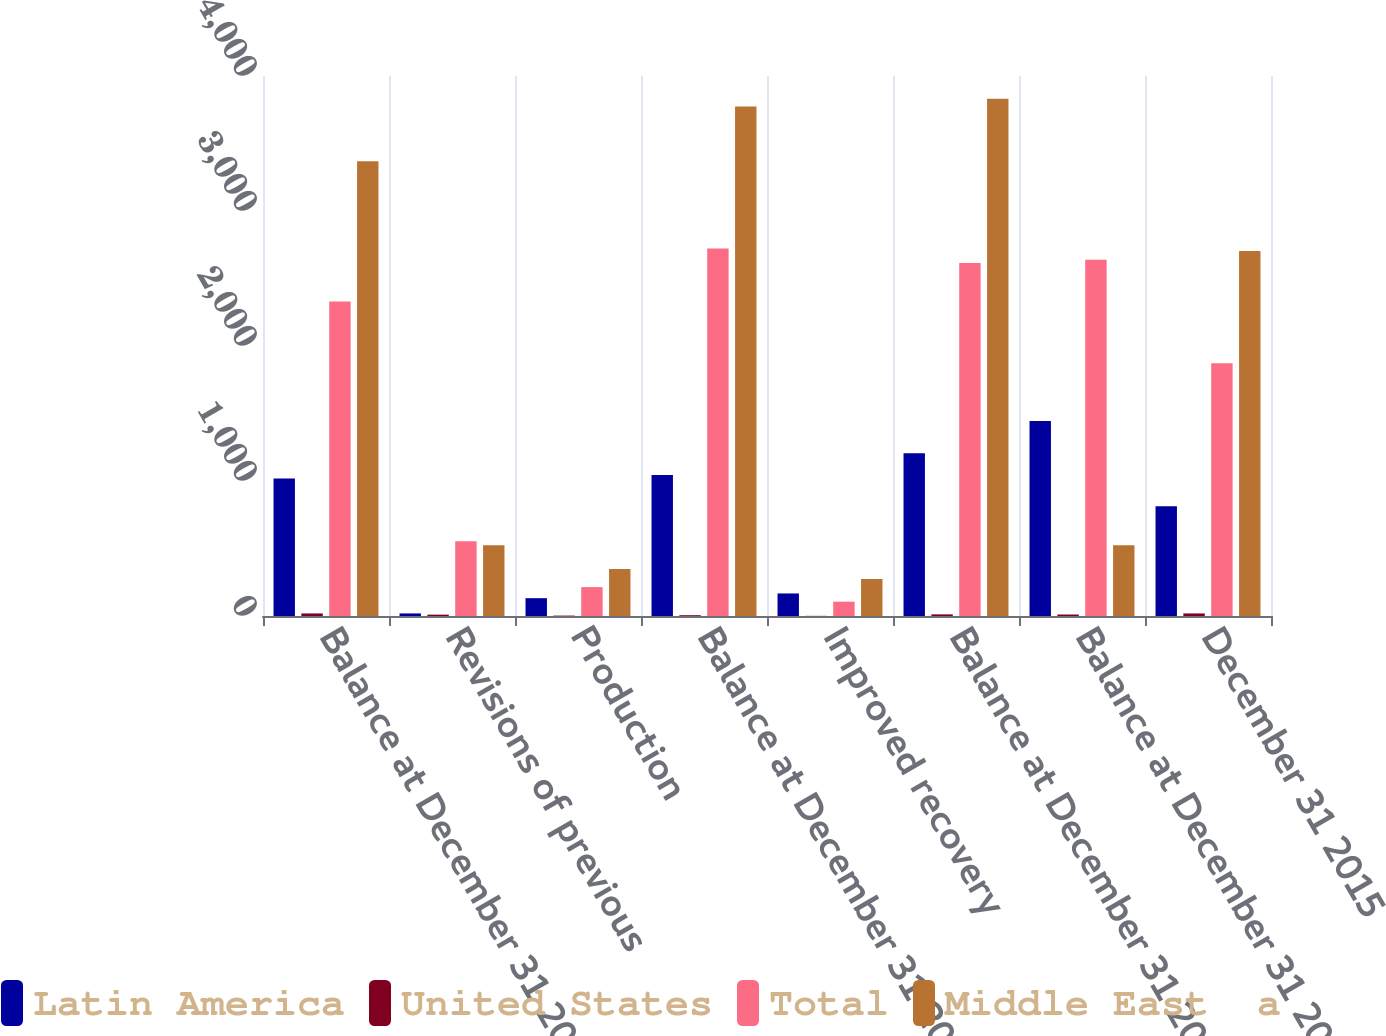Convert chart to OTSL. <chart><loc_0><loc_0><loc_500><loc_500><stacked_bar_chart><ecel><fcel>Balance at December 31 2015<fcel>Revisions of previous<fcel>Production<fcel>Balance at December 31 2016<fcel>Improved recovery<fcel>Balance at December 31 2017<fcel>Balance at December 31 2018<fcel>December 31 2015<nl><fcel>Latin America<fcel>1019<fcel>19<fcel>132<fcel>1045<fcel>167<fcel>1205<fcel>1445<fcel>813<nl><fcel>United States<fcel>19<fcel>10<fcel>3<fcel>6<fcel>1<fcel>12<fcel>11<fcel>19<nl><fcel>Total<fcel>2330<fcel>554<fcel>214<fcel>2723<fcel>106<fcel>2614<fcel>2639<fcel>1872<nl><fcel>Middle East  a<fcel>3368<fcel>525<fcel>349<fcel>3774<fcel>274<fcel>3831<fcel>525<fcel>2704<nl></chart> 